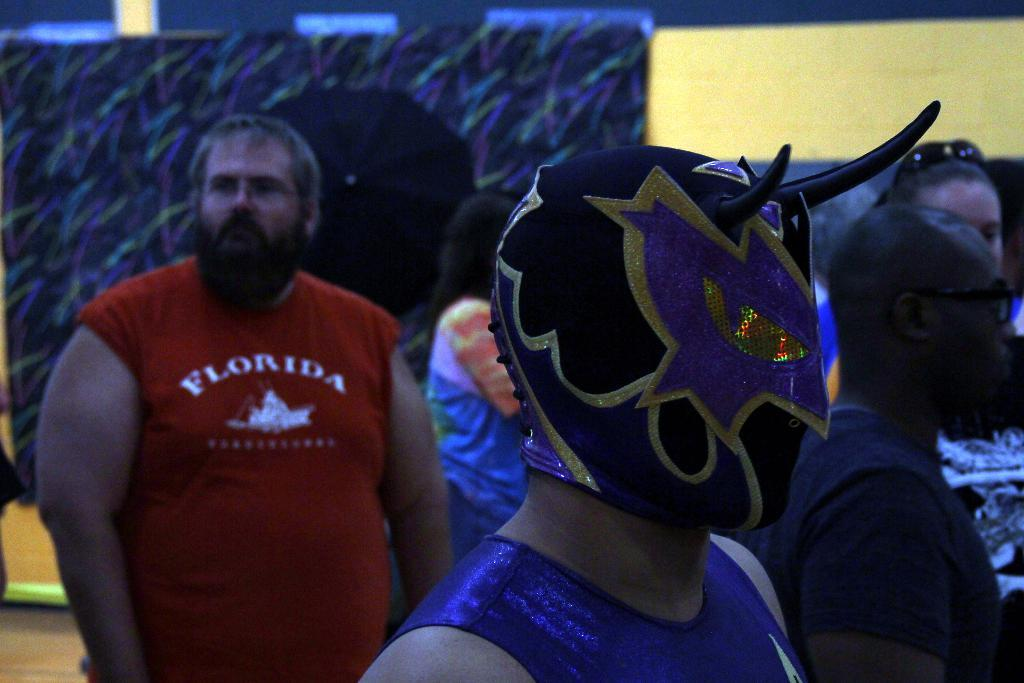What is the main subject of the image? The main subject of the image is a group of people. Can you describe the position of one person in the group? There is a person in the middle of the image. What is the person in the middle wearing? The person in the middle is wearing a mask. How many sheep are present in the image? There are no sheep present in the image. What type of structure can be seen in the background of the image? There is no structure visible in the image; it only features a group of people. 